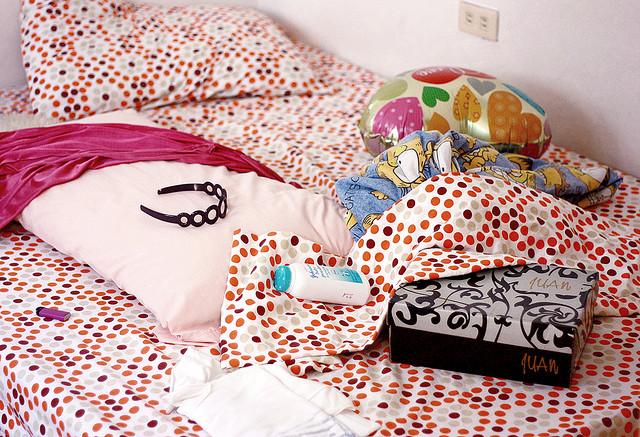Is there a black headband on the bed?
Write a very short answer. Yes. What color is the bed?
Give a very brief answer. Multi colored. Does this person need to clean up?
Write a very short answer. Yes. Is there a balloon on the bed?
Short answer required. Yes. 